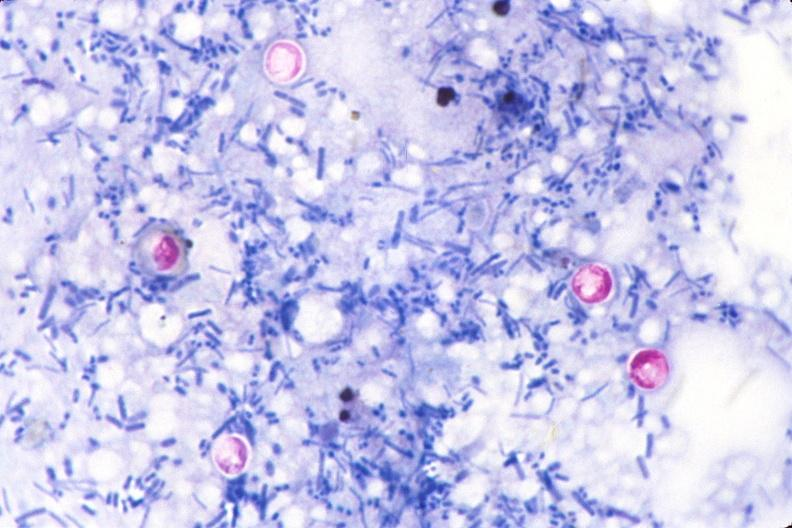does cryptosporidia stain of feces?
Answer the question using a single word or phrase. Yes 